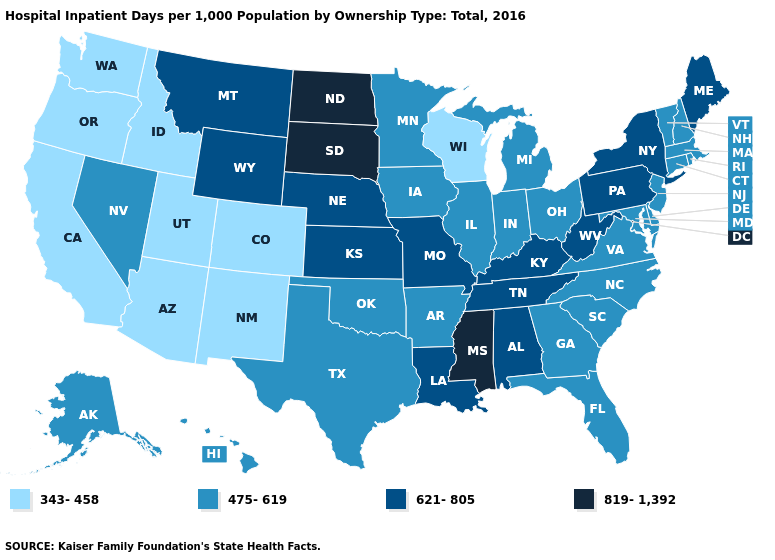What is the value of South Dakota?
Write a very short answer. 819-1,392. What is the highest value in the USA?
Quick response, please. 819-1,392. Name the states that have a value in the range 475-619?
Write a very short answer. Alaska, Arkansas, Connecticut, Delaware, Florida, Georgia, Hawaii, Illinois, Indiana, Iowa, Maryland, Massachusetts, Michigan, Minnesota, Nevada, New Hampshire, New Jersey, North Carolina, Ohio, Oklahoma, Rhode Island, South Carolina, Texas, Vermont, Virginia. Among the states that border New Jersey , does Pennsylvania have the lowest value?
Write a very short answer. No. Does New Jersey have the lowest value in the Northeast?
Keep it brief. Yes. Among the states that border Connecticut , which have the highest value?
Answer briefly. New York. Which states have the lowest value in the Northeast?
Be succinct. Connecticut, Massachusetts, New Hampshire, New Jersey, Rhode Island, Vermont. Is the legend a continuous bar?
Be succinct. No. What is the value of Nebraska?
Short answer required. 621-805. What is the value of Iowa?
Quick response, please. 475-619. Which states have the lowest value in the USA?
Be succinct. Arizona, California, Colorado, Idaho, New Mexico, Oregon, Utah, Washington, Wisconsin. Among the states that border New Jersey , does New York have the lowest value?
Be succinct. No. Does Delaware have the same value as Iowa?
Concise answer only. Yes. Among the states that border Nebraska , does South Dakota have the highest value?
Keep it brief. Yes. Does North Dakota have the same value as South Dakota?
Be succinct. Yes. 